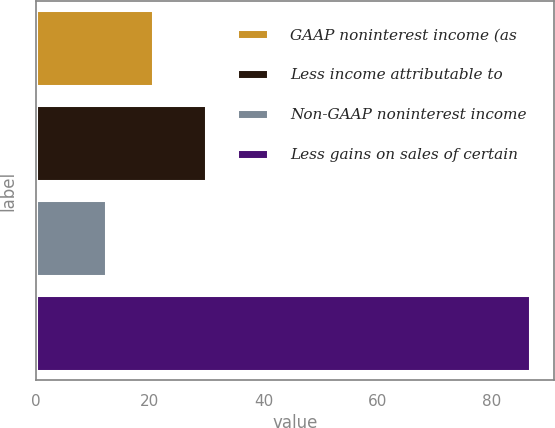Convert chart. <chart><loc_0><loc_0><loc_500><loc_500><bar_chart><fcel>GAAP noninterest income (as<fcel>Less income attributable to<fcel>Non-GAAP noninterest income<fcel>Less gains on sales of certain<nl><fcel>20.54<fcel>29.8<fcel>12.27<fcel>86.7<nl></chart> 